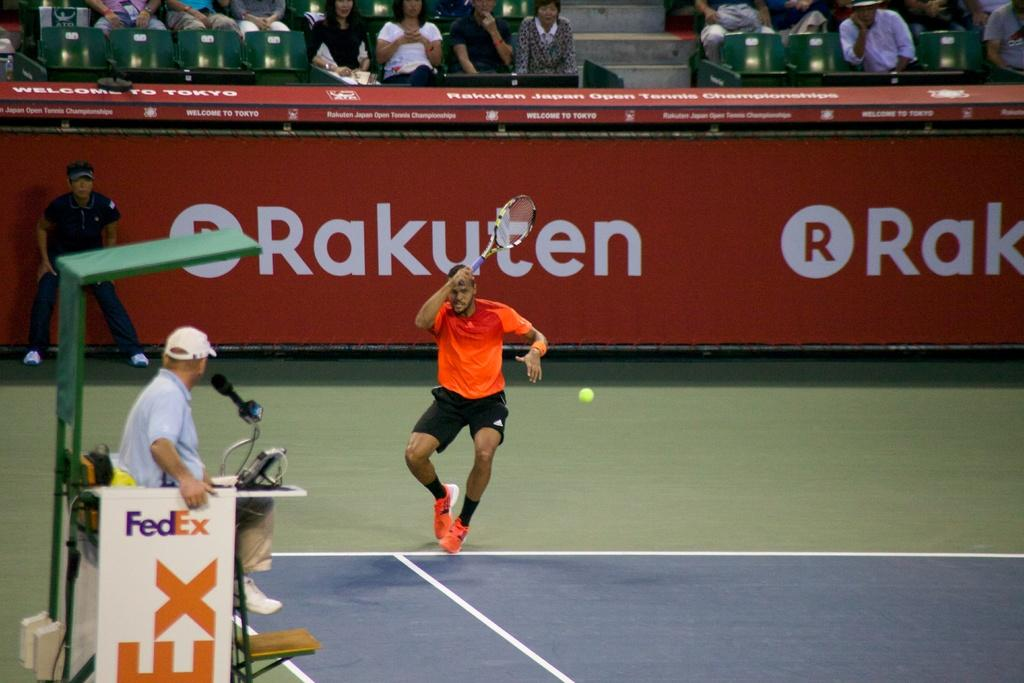What are the people in the image doing? There are people sitting on chairs, a person standing, a person jumping and holding a bat, and a person holding a banner in the image. Can you describe the person who is standing? The person standing is wearing a cap. What is the person holding a bat doing? The person is jumping and holding a bat in the image. What is the person holding a banner doing? The person is holding a banner in the image. What object is on the table in the image? There is a microphone on a table in the image. What type of arithmetic problem is being solved by the person holding the bat? There is no arithmetic problem present in the image; it features people engaged in various activities, including a person jumping and holding a bat. What type of trade is being conducted by the person holding the banner? There is no trade being conducted in the image; the person holding the banner is simply holding a banner. 